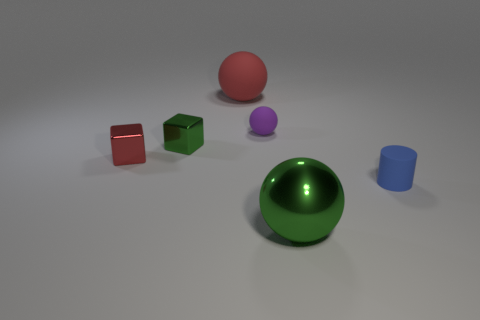What number of rubber things are big things or tiny blue cylinders?
Provide a succinct answer. 2. There is a object that is right of the metallic thing in front of the tiny shiny object left of the green block; what is it made of?
Ensure brevity in your answer.  Rubber. What material is the green object that is on the left side of the large sphere that is behind the shiny sphere?
Your answer should be very brief. Metal. Does the blue rubber cylinder that is to the right of the purple matte ball have the same size as the green metallic thing on the left side of the large rubber thing?
Give a very brief answer. Yes. What number of small objects are either blocks or shiny things?
Your answer should be compact. 2. How many things are either small rubber objects behind the small blue matte thing or small brown things?
Your answer should be very brief. 1. How many other objects are the same shape as the big red thing?
Provide a short and direct response. 2. What number of cyan objects are cylinders or matte spheres?
Make the answer very short. 0. What is the color of the small object that is the same material as the red block?
Give a very brief answer. Green. Does the ball that is in front of the small green block have the same material as the large object that is behind the small green thing?
Offer a very short reply. No. 